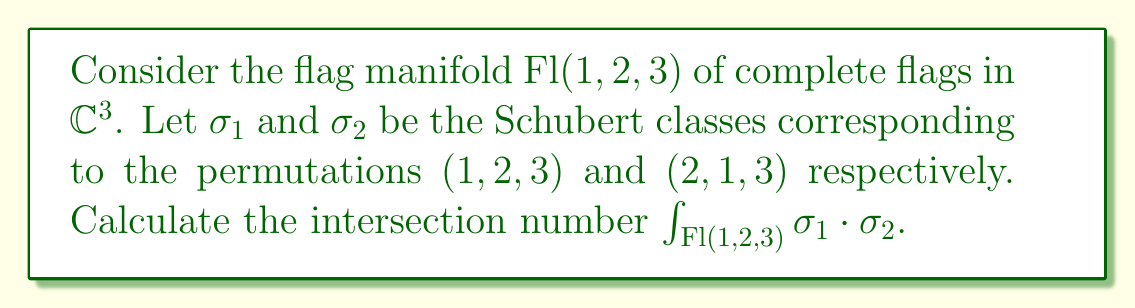Teach me how to tackle this problem. To solve this problem, we'll follow these steps:

1) First, recall that the dimension of $\text{Fl}(1,2,3)$ is 3.

2) The Schubert class $\sigma_1$ corresponds to the permutation $(1,2,3)$, which has length 0. Thus, $\text{codim}(\sigma_1) = 0$.

3) The Schubert class $\sigma_2$ corresponds to the permutation $(2,1,3)$, which has length 1. Thus, $\text{codim}(\sigma_2) = 1$.

4) For the intersection to be non-zero, we need:
   $$\text{codim}(\sigma_1) + \text{codim}(\sigma_2) = \dim(\text{Fl}(1,2,3))$$

5) Indeed, $0 + 1 = 1 \neq 3$, so the intersection number is 0.

6) Alternatively, we can use the Littlewood-Richardson rule for flag manifolds. The product $\sigma_1 \cdot \sigma_2$ corresponds to the Littlewood-Richardson coefficient $c_{(1,2,3),(2,1,3)}^{(2,1,3)}$, which is 1.

7) However, this product represents a 1-dimensional class in a 3-dimensional manifold, so its integral over the entire manifold is still 0.

Therefore, $\int_{\text{Fl}(1,2,3)} \sigma_1 \cdot \sigma_2 = 0$.
Answer: 0 